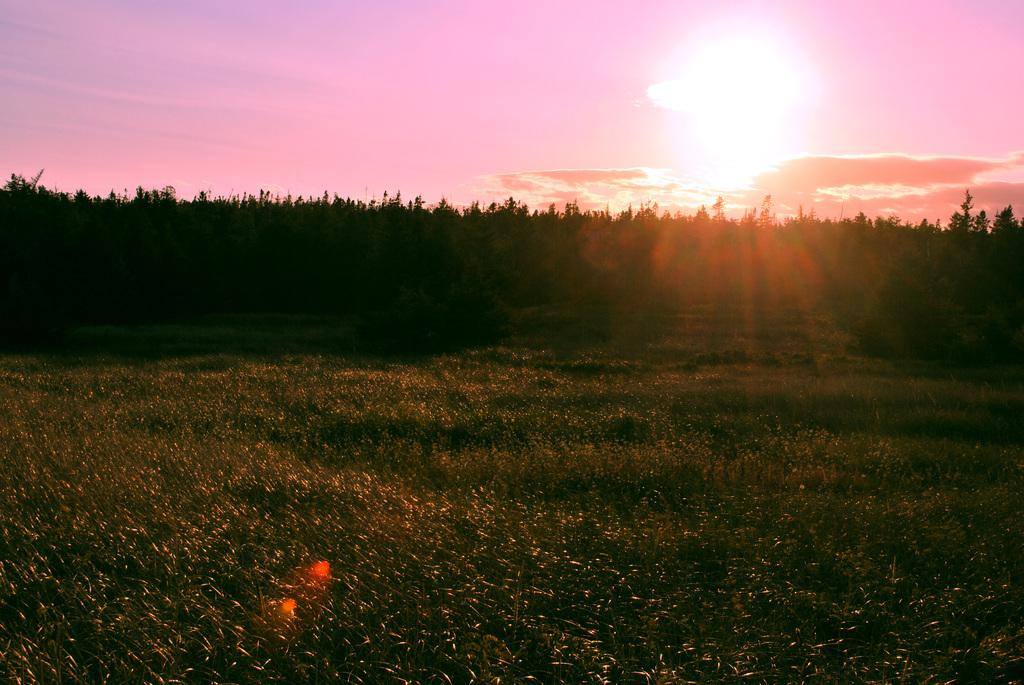What type of vegetation can be seen in the image? There are trees in the image. What is visible at the top of the image? The sky is visible at the top of the image. What can be seen in the sky? There are clouds and the sun observable in the sky. What type of ground surface is visible at the bottom of the image? There is grass at the bottom of the image. Where is the sister's cake located in the image? There is no sister or cake present in the image. What type of range can be seen in the image? There is no range present in the image. 